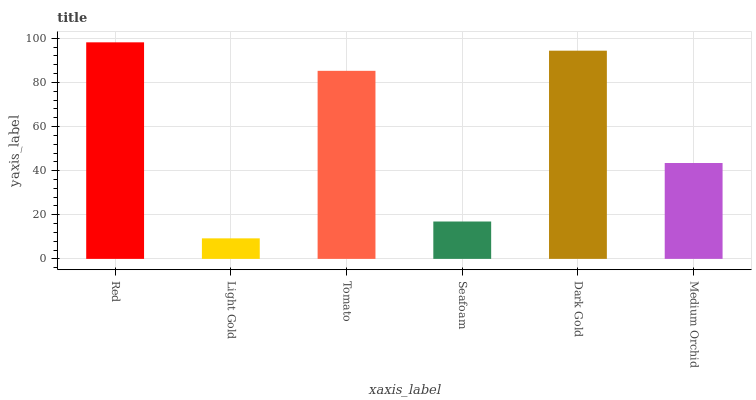Is Light Gold the minimum?
Answer yes or no. Yes. Is Red the maximum?
Answer yes or no. Yes. Is Tomato the minimum?
Answer yes or no. No. Is Tomato the maximum?
Answer yes or no. No. Is Tomato greater than Light Gold?
Answer yes or no. Yes. Is Light Gold less than Tomato?
Answer yes or no. Yes. Is Light Gold greater than Tomato?
Answer yes or no. No. Is Tomato less than Light Gold?
Answer yes or no. No. Is Tomato the high median?
Answer yes or no. Yes. Is Medium Orchid the low median?
Answer yes or no. Yes. Is Seafoam the high median?
Answer yes or no. No. Is Dark Gold the low median?
Answer yes or no. No. 